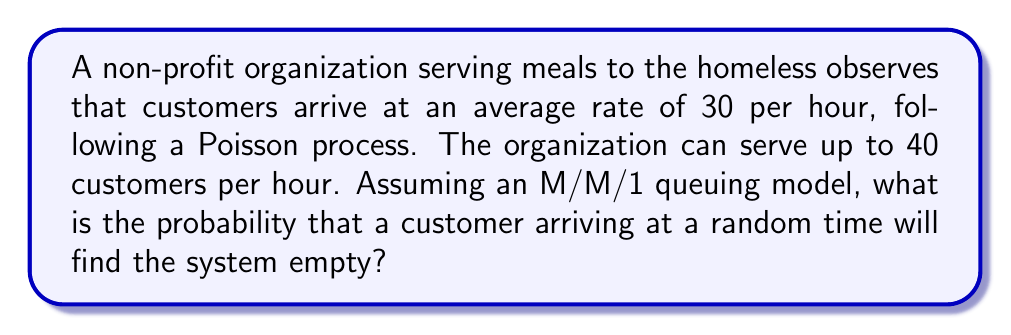Show me your answer to this math problem. Let's approach this step-by-step using queuing theory:

1) In an M/M/1 queue:
   - $\lambda$ = arrival rate
   - $\mu$ = service rate

2) Given:
   $\lambda = 30$ customers/hour
   $\mu = 40$ customers/hour

3) The utilization factor $\rho$ is defined as:

   $$\rho = \frac{\lambda}{\mu}$$

4) Calculate $\rho$:

   $$\rho = \frac{30}{40} = 0.75$$

5) In an M/M/1 queue, the probability of the system being empty ($P_0$) is given by:

   $$P_0 = 1 - \rho$$

6) Calculate $P_0$:

   $$P_0 = 1 - 0.75 = 0.25$$

7) Therefore, the probability that an arriving customer finds the system empty is 0.25 or 25%.

This result indicates that there's a 25% chance that a customer arriving at a random time will find no one else in the queue, allowing the non-profit to serve them immediately. This information can help the organization plan its resources and potentially improve its service to the community.
Answer: 0.25 